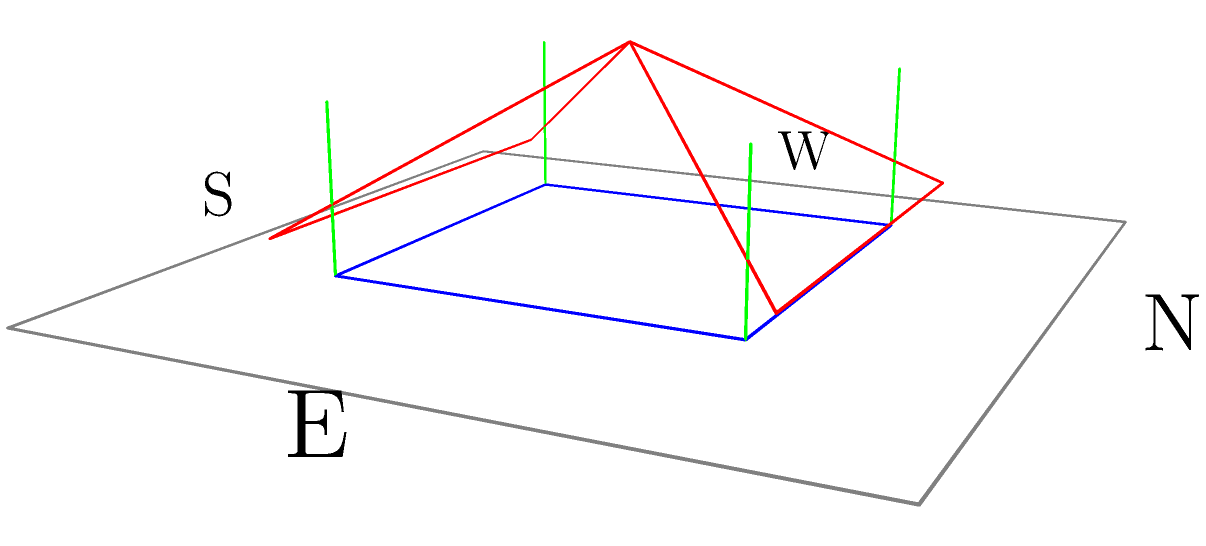In traditional East Asian architecture, the orientation of buildings is crucial. Given the 3D representation of a traditional East Asian structure above, which direction is the main entrance typically facing according to feng shui principles? To answer this question, we need to consider the following steps:

1. Recognize the structure: The image shows a simplified 3D model of a traditional East Asian building with a distinctive sloped roof and supporting pillars.

2. Identify the orientation: The diagram includes cardinal directions (N, S, E, W) to help with orientation.

3. Recall feng shui principles: In traditional East Asian architecture, especially Chinese, the main entrance is typically oriented towards the south. This is based on several feng shui concepts:

   a) The south represents fire element, associated with warmth and energy.
   b) Southern exposure maximizes sunlight, which is considered auspicious.
   c) In the northern hemisphere, south-facing buildings receive more sunlight throughout the year.

4. Analyze the structure: The model shows a symmetrical building. In East Asian architecture, the main entrance is usually centered on the main facade.

5. Conclude: Given the orientation labels and feng shui principles, the main entrance would typically face south in this representation.
Answer: South 